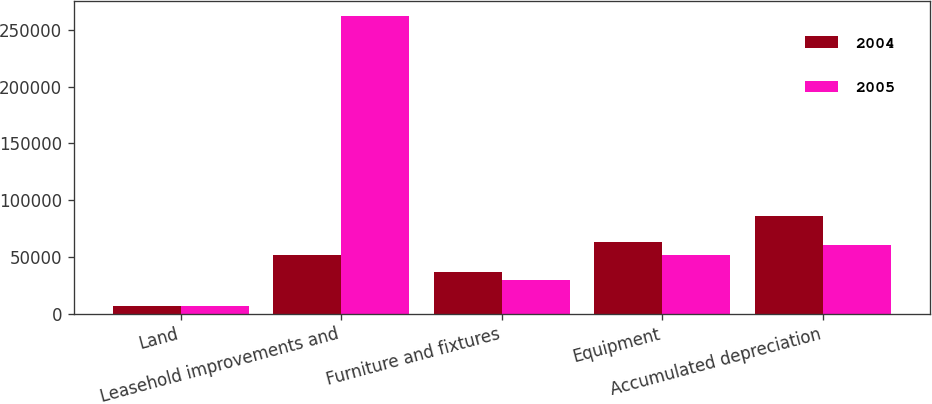<chart> <loc_0><loc_0><loc_500><loc_500><stacked_bar_chart><ecel><fcel>Land<fcel>Leasehold improvements and<fcel>Furniture and fixtures<fcel>Equipment<fcel>Accumulated depreciation<nl><fcel>2004<fcel>6557<fcel>51907<fcel>36266<fcel>63356<fcel>86426<nl><fcel>2005<fcel>6298<fcel>262332<fcel>29814<fcel>51907<fcel>60478<nl></chart> 